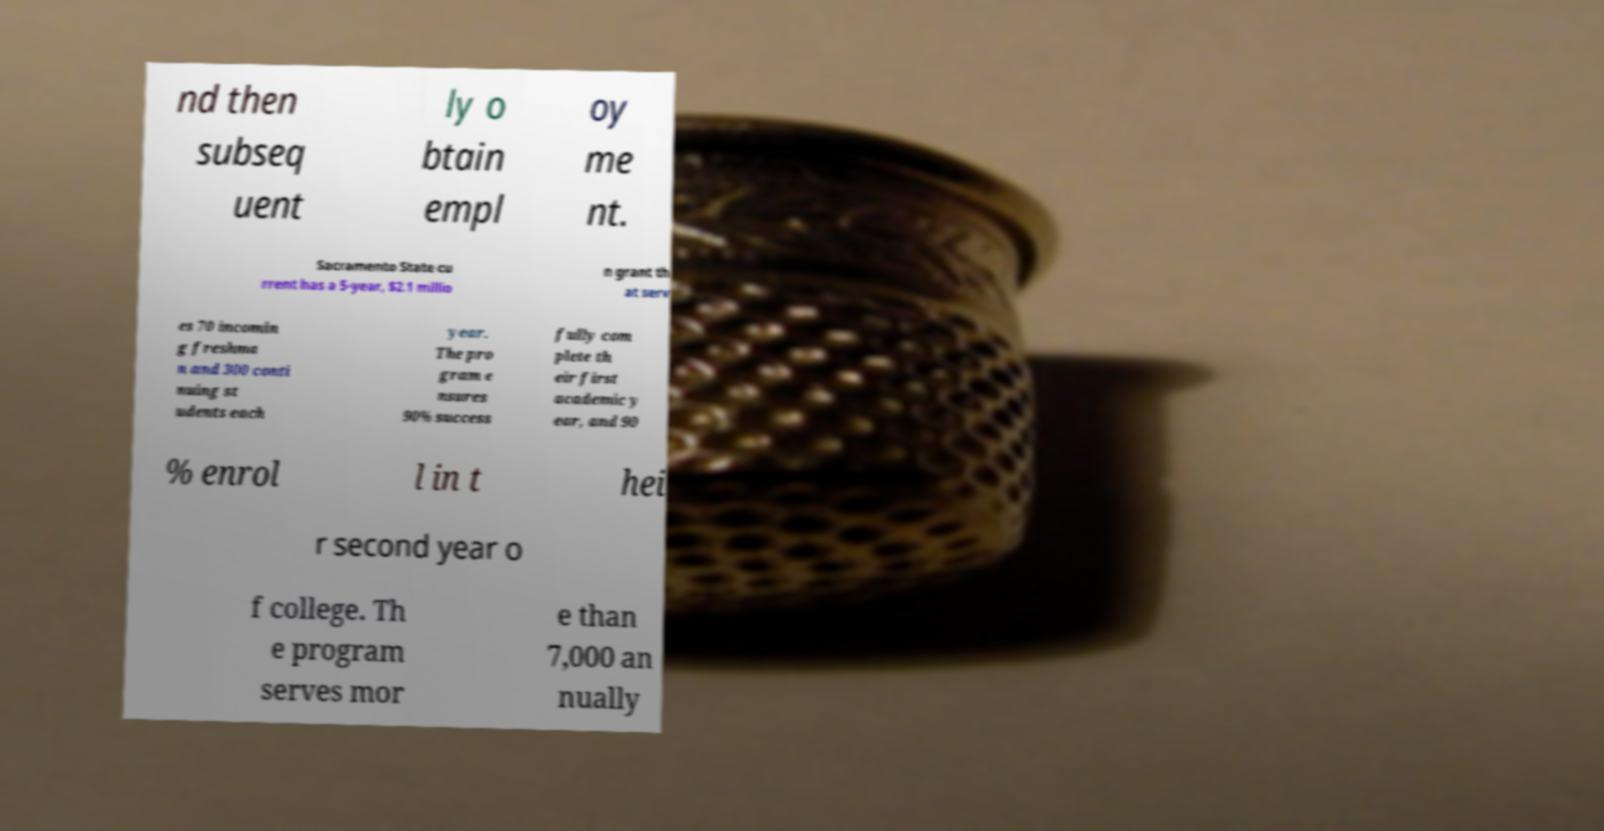There's text embedded in this image that I need extracted. Can you transcribe it verbatim? nd then subseq uent ly o btain empl oy me nt. Sacramento State cu rrent has a 5-year, $2.1 millio n grant th at serv es 70 incomin g freshma n and 300 conti nuing st udents each year. The pro gram e nsures 90% success fully com plete th eir first academic y ear, and 90 % enrol l in t hei r second year o f college. Th e program serves mor e than 7,000 an nually 